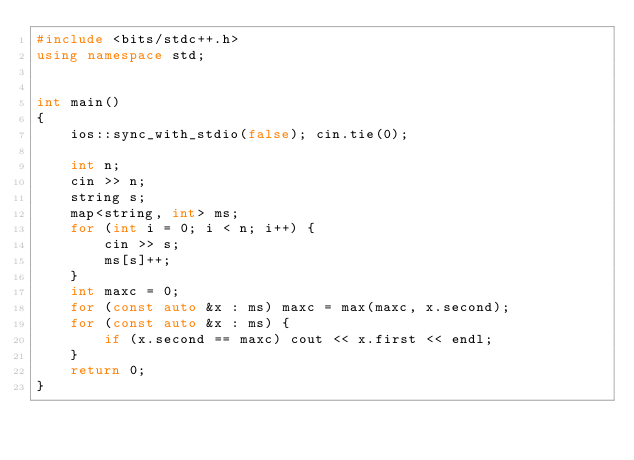<code> <loc_0><loc_0><loc_500><loc_500><_C++_>#include <bits/stdc++.h>
using namespace std;


int main()
{
    ios::sync_with_stdio(false); cin.tie(0);

    int n;
    cin >> n;
    string s;
    map<string, int> ms;
    for (int i = 0; i < n; i++) {
        cin >> s;
        ms[s]++;
    }
    int maxc = 0;
    for (const auto &x : ms) maxc = max(maxc, x.second);
    for (const auto &x : ms) {
        if (x.second == maxc) cout << x.first << endl;
    }
    return 0;
}
</code> 